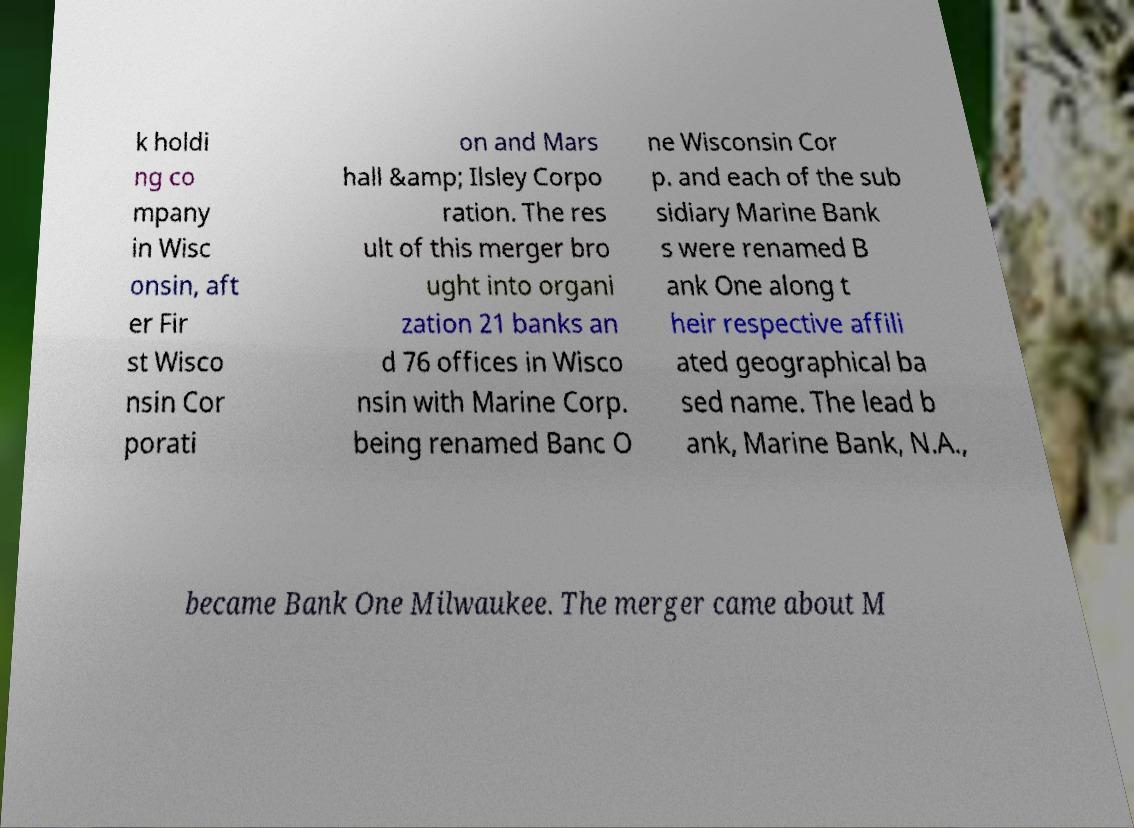I need the written content from this picture converted into text. Can you do that? k holdi ng co mpany in Wisc onsin, aft er Fir st Wisco nsin Cor porati on and Mars hall &amp; Ilsley Corpo ration. The res ult of this merger bro ught into organi zation 21 banks an d 76 offices in Wisco nsin with Marine Corp. being renamed Banc O ne Wisconsin Cor p. and each of the sub sidiary Marine Bank s were renamed B ank One along t heir respective affili ated geographical ba sed name. The lead b ank, Marine Bank, N.A., became Bank One Milwaukee. The merger came about M 